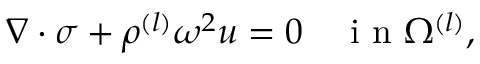<formula> <loc_0><loc_0><loc_500><loc_500>\begin{array} { r } { \nabla \cdot \sigma + \rho ^ { ( l ) } \omega ^ { 2 } u = 0 \quad i n \Omega ^ { ( l ) } , } \end{array}</formula> 